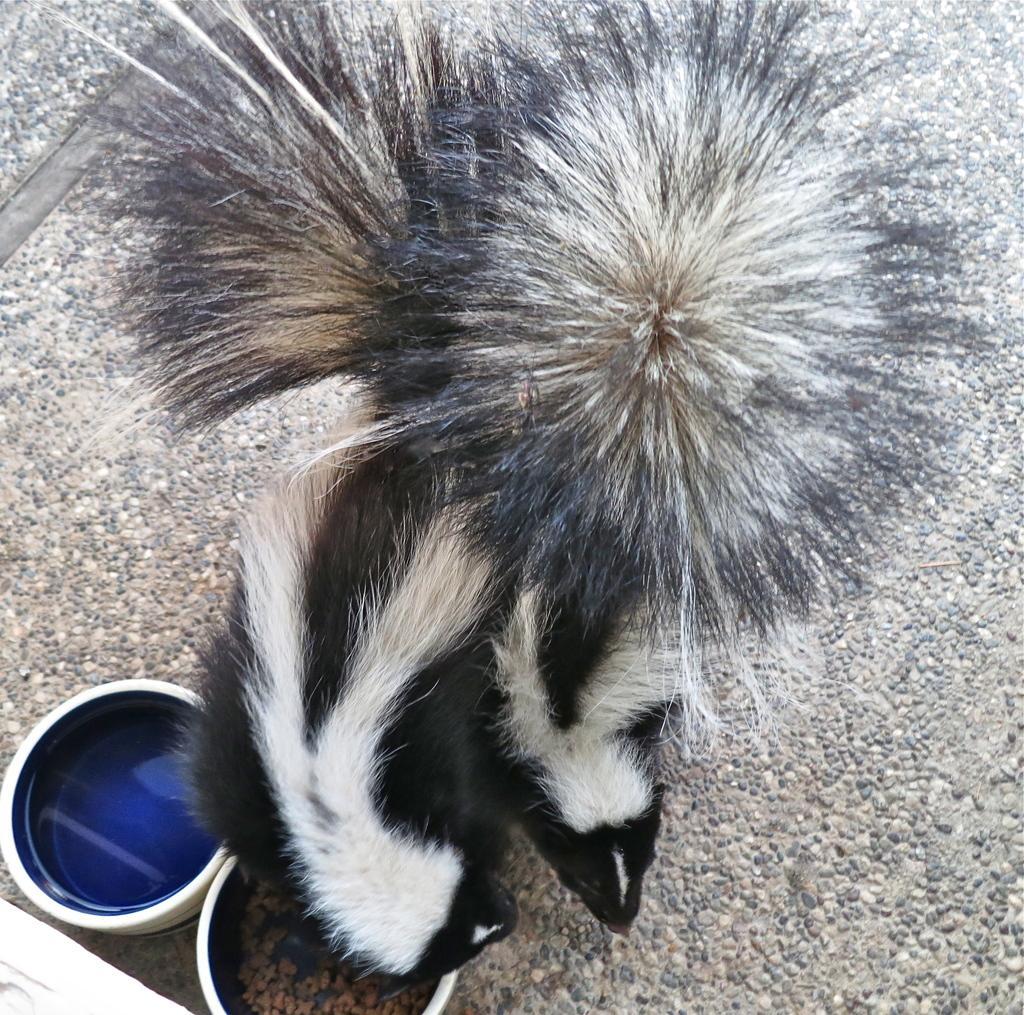Can you describe this image briefly? In this image I can see there are two animals with spur, they are in black and white color. At the bottom there are two bowls. 